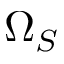Convert formula to latex. <formula><loc_0><loc_0><loc_500><loc_500>\Omega _ { S }</formula> 